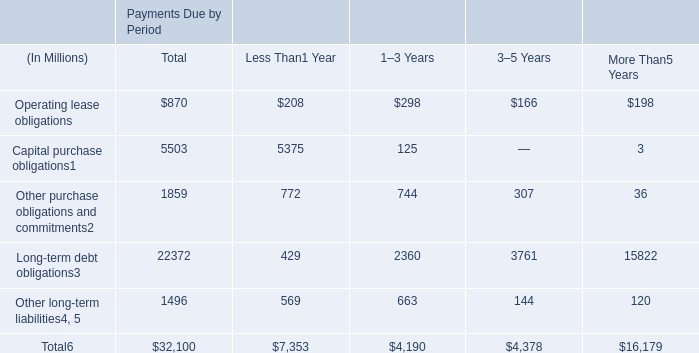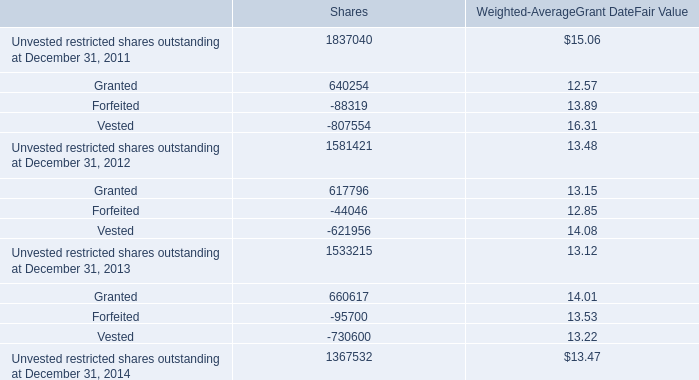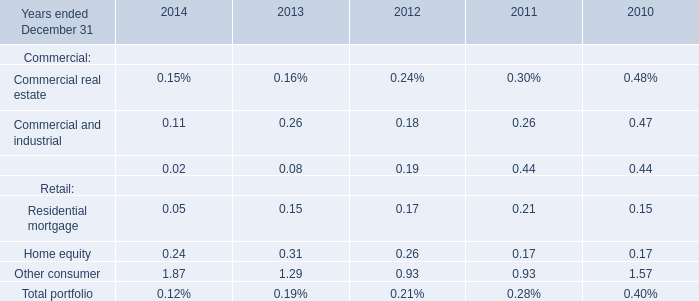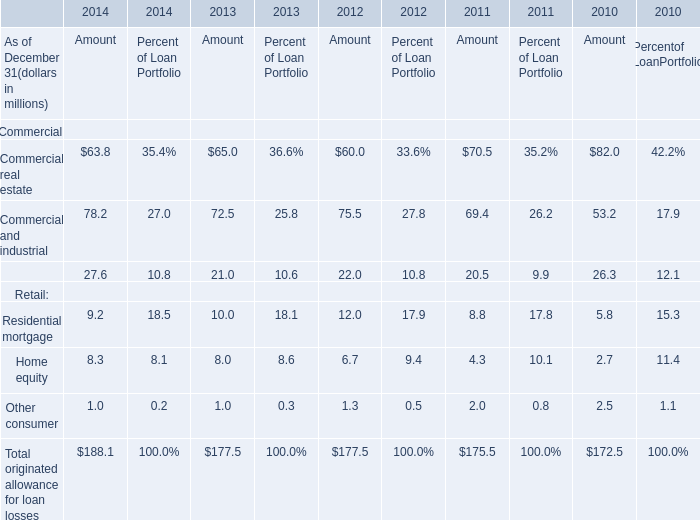What was the total amount of Commercial and industrial in the range of 0 and 1 for Years ended December 31 ? 
Computations: ((((0.11 + 0.26) + 0.18) + 0.26) + 0.47)
Answer: 1.28. 